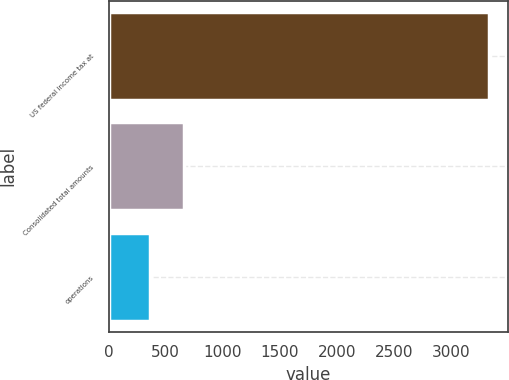Convert chart. <chart><loc_0><loc_0><loc_500><loc_500><bar_chart><fcel>US federal income tax at<fcel>Consolidated total amounts<fcel>operations<nl><fcel>3331<fcel>657.1<fcel>360<nl></chart> 